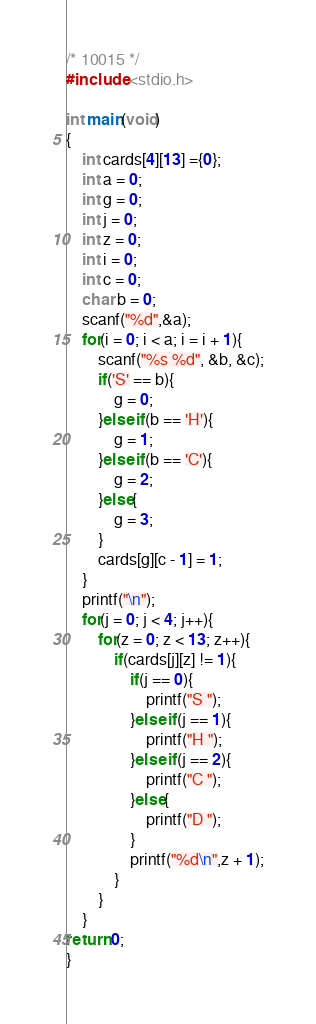Convert code to text. <code><loc_0><loc_0><loc_500><loc_500><_C_>/* 10015 */
#include <stdio.h>

int main(void)
{
	int cards[4][13] ={0};
	int a = 0;
	int g = 0;
	int j = 0;
	int z = 0;
	int i = 0;
	int c = 0;
	char b = 0;
	scanf("%d",&a);
	for(i = 0; i < a; i = i + 1){
		scanf("%s %d", &b, &c);
		if('S' == b){
			g = 0;
		}else if(b == 'H'){
			g = 1;
		}else if(b == 'C'){
			g = 2;
		}else{
			g = 3;
		} 
		cards[g][c - 1] = 1;
	}
	printf("\n");
	for(j = 0; j < 4; j++){
		for(z = 0; z < 13; z++){
			if(cards[j][z] != 1){
				if(j == 0){
					printf("S ");
				}else if(j == 1){
					printf("H ");
				}else if(j == 2){
					printf("C ");
				}else{
					printf("D ");
				}
				printf("%d\n",z + 1);
			}
		}
	}
return 0;
}</code> 